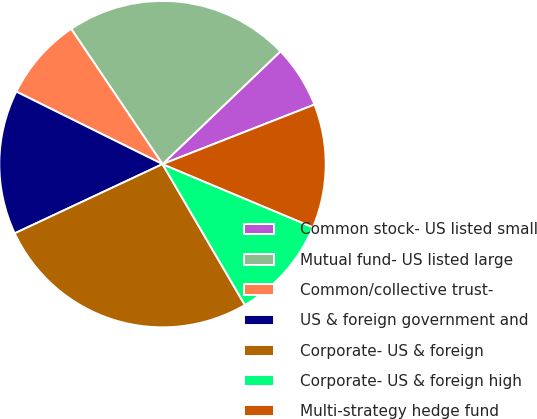<chart> <loc_0><loc_0><loc_500><loc_500><pie_chart><fcel>Common stock- US listed small<fcel>Mutual fund- US listed large<fcel>Common/collective trust-<fcel>US & foreign government and<fcel>Corporate- US & foreign<fcel>Corporate- US & foreign high<fcel>Multi-strategy hedge fund<nl><fcel>6.2%<fcel>22.31%<fcel>8.22%<fcel>14.3%<fcel>26.45%<fcel>10.25%<fcel>12.27%<nl></chart> 